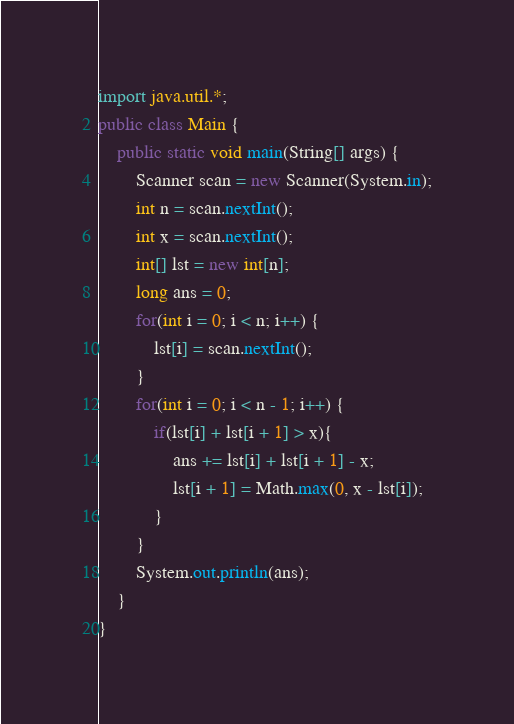<code> <loc_0><loc_0><loc_500><loc_500><_Java_>import java.util.*;
public class Main {
    public static void main(String[] args) {
        Scanner scan = new Scanner(System.in);
        int n = scan.nextInt();
        int x = scan.nextInt();
        int[] lst = new int[n];
        long ans = 0;
        for(int i = 0; i < n; i++) {
            lst[i] = scan.nextInt();
        }
        for(int i = 0; i < n - 1; i++) {
            if(lst[i] + lst[i + 1] > x){
                ans += lst[i] + lst[i + 1] - x;
                lst[i + 1] = Math.max(0, x - lst[i]);
            }
        }
        System.out.println(ans);
    }
}</code> 